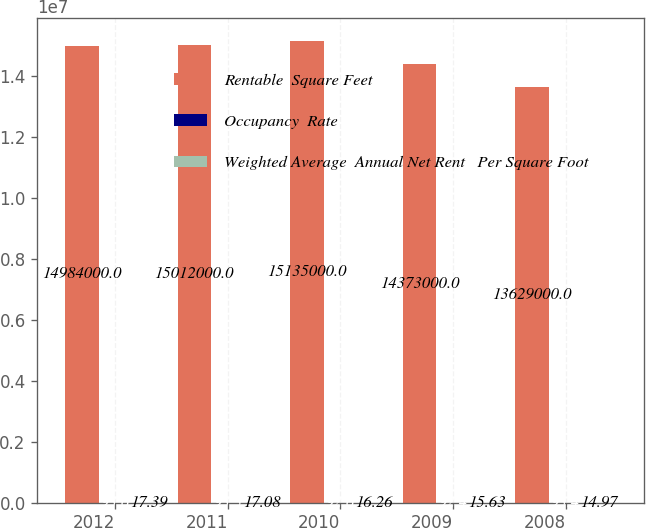<chart> <loc_0><loc_0><loc_500><loc_500><stacked_bar_chart><ecel><fcel>2012<fcel>2011<fcel>2010<fcel>2009<fcel>2008<nl><fcel>Rentable  Square Feet<fcel>1.4984e+07<fcel>1.5012e+07<fcel>1.5135e+07<fcel>1.4373e+07<fcel>1.3629e+07<nl><fcel>Occupancy  Rate<fcel>93.6<fcel>93.3<fcel>92.6<fcel>92.4<fcel>93.4<nl><fcel>Weighted Average  Annual Net Rent   Per Square Foot<fcel>17.39<fcel>17.08<fcel>16.26<fcel>15.63<fcel>14.97<nl></chart> 